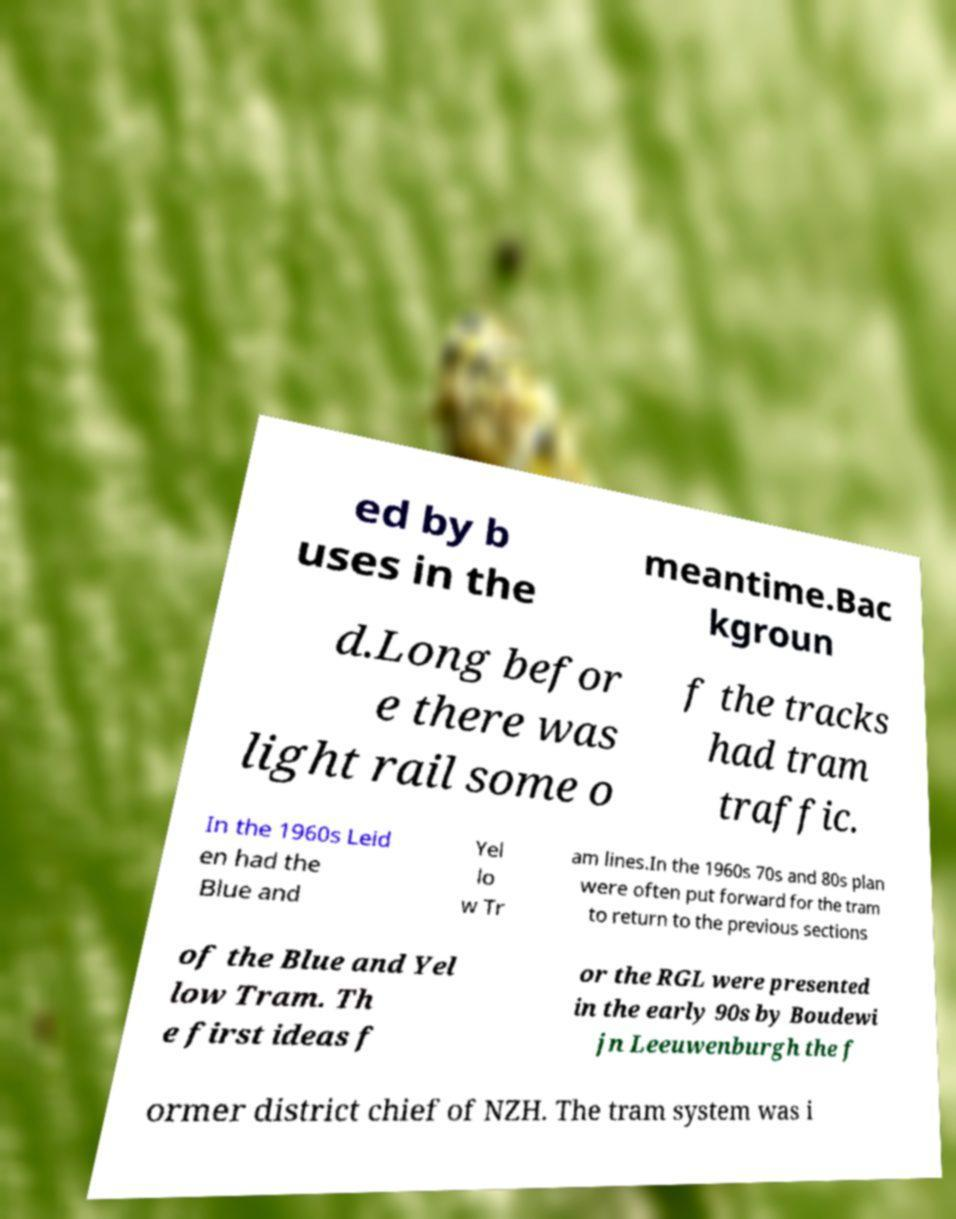What messages or text are displayed in this image? I need them in a readable, typed format. ed by b uses in the meantime.Bac kgroun d.Long befor e there was light rail some o f the tracks had tram traffic. In the 1960s Leid en had the Blue and Yel lo w Tr am lines.In the 1960s 70s and 80s plan were often put forward for the tram to return to the previous sections of the Blue and Yel low Tram. Th e first ideas f or the RGL were presented in the early 90s by Boudewi jn Leeuwenburgh the f ormer district chief of NZH. The tram system was i 